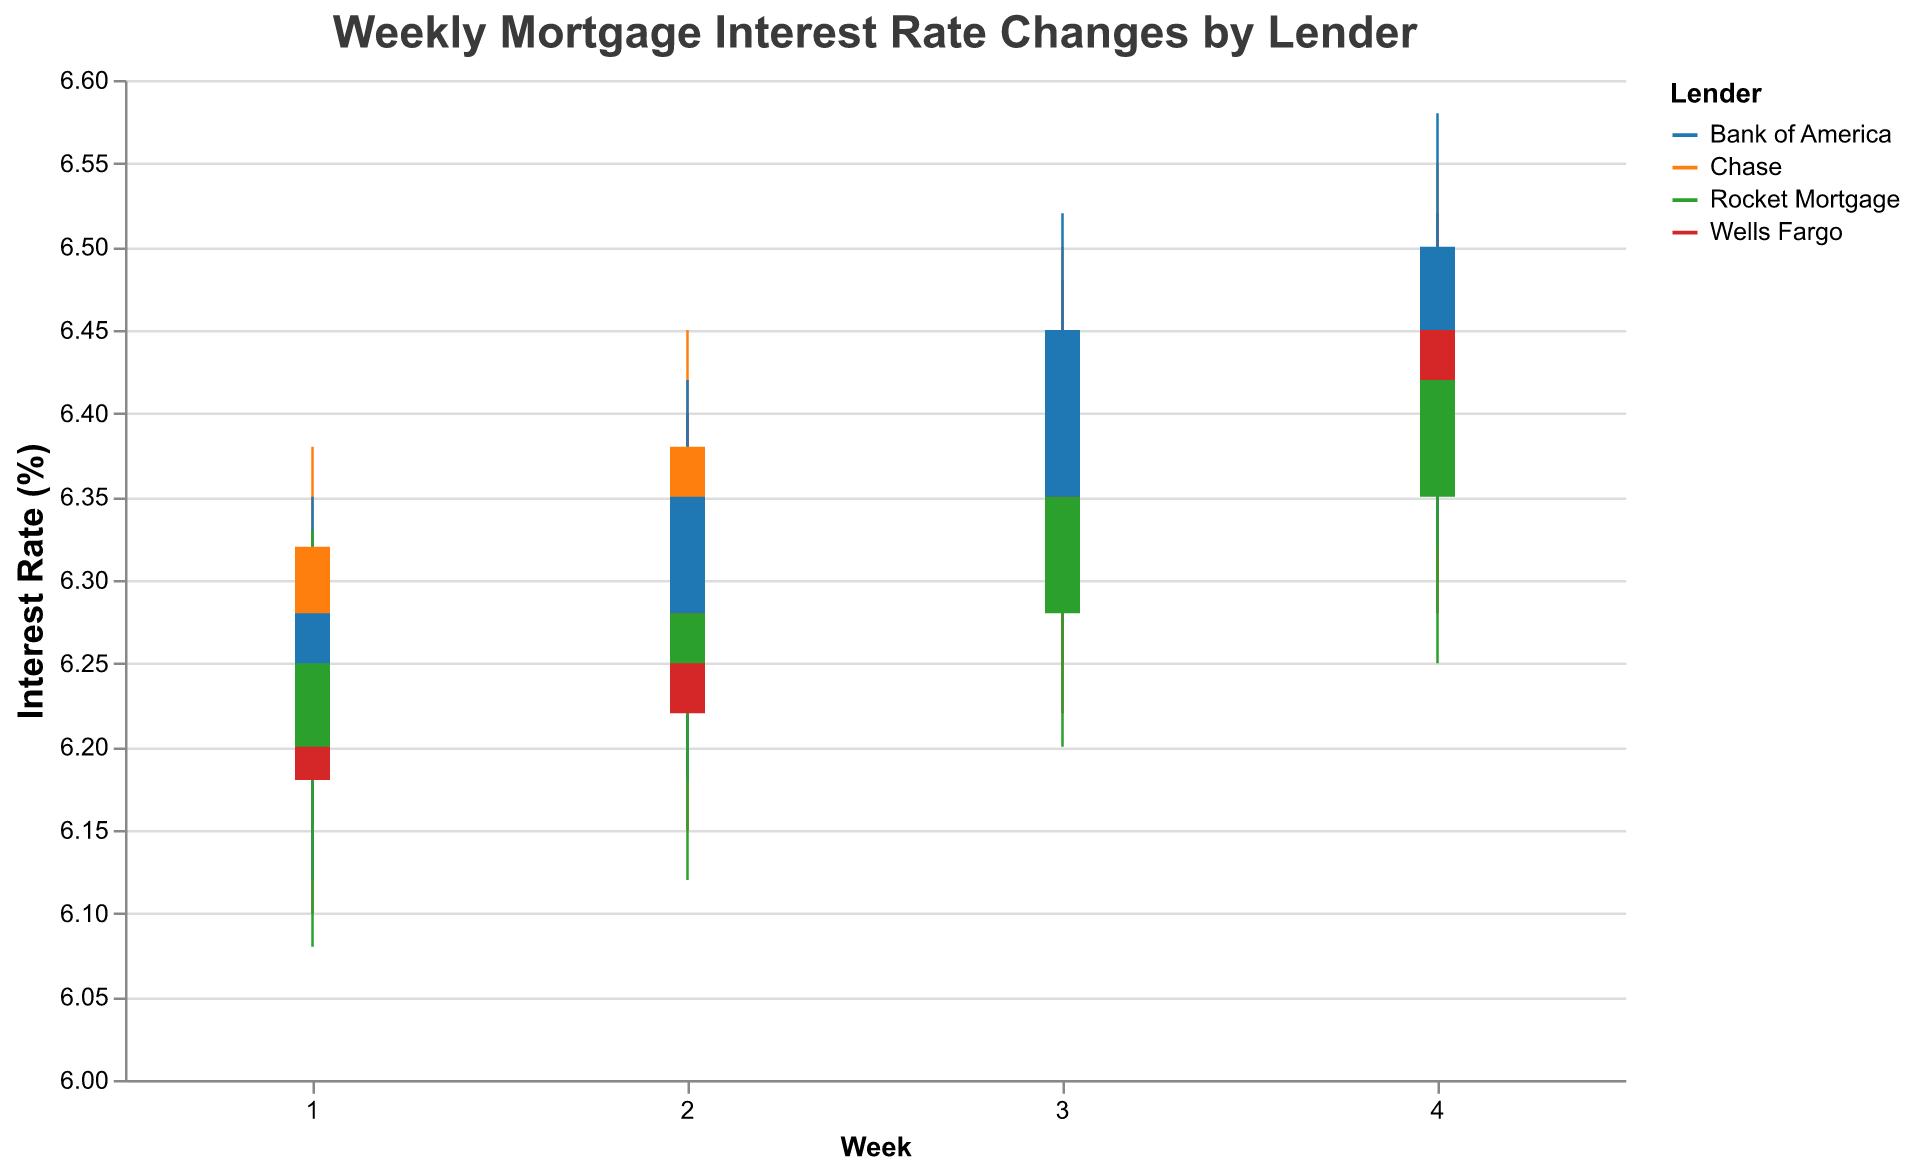What's the title of the figure? The title is prominently displayed at the top of the figure and reads "Weekly Mortgage Interest Rate Changes by Lender".
Answer: Weekly Mortgage Interest Rate Changes by Lender What are the lenders shown in the figure? The lenders are distinguished by different colors and indicated in the legends or tooltips. They are Chase, Wells Fargo, Bank of America, and Rocket Mortgage.
Answer: Chase, Wells Fargo, Bank of America, Rocket Mortgage Which week has the highest closing interest rates for Rocket Mortgage? By looking at the close values for Rocket Mortgage across all weeks, Week 4 has the highest closing rate of 6.42%.
Answer: Week 4 What is the highest interest rate recorded across all lenders? The highest rate can be found by comparing the high values for all lenders and weeks. The highest value is 6.58% shown by Bank of America in Week 4.
Answer: 6.58% In Week 2, which lender had the widest range between the high and low interest rates? Calculate the range (High - Low) for each lender in week 2. Chase: 6.45 - 6.20 = 0.25, Wells Fargo: 6.40 - 6.15 = 0.25, Bank of America: 6.42 - 6.18 = 0.24, Rocket Mortgage: 6.38 - 6.12 = 0.26. Rocket Mortgage has the widest range.
Answer: Rocket Mortgage What trend do you observe in Chase’s weekly closing rates? Chase’s weekly closing rates show a steady increase: Week 1: 6.32, Week 2: 6.38, Week 3: 6.42, Week 4: 6.48.
Answer: Increasing trend Which lender showed the lowest starting interest rate in Week 1? Check the open values for Week 1. Chase: 6.25, Wells Fargo: 6.18, Bank of America: 6.22, Rocket Mortgage: 6.20. The lowest starting rate was from Wells Fargo at 6.18%.
Answer: Wells Fargo What was the average closing interest rate for Bank of America over the four weeks? Add the closing rates for Bank of America across all weeks and divide by the number of weeks: (6.28 + 6.35 + 6.45 + 6.50) / 4 = 6.395%.
Answer: 6.395% How does Rocket Mortgage's closing interest rate compare from Week 1 to Week 4? Compare the closing rates for Rocket Mortgage in Week 1 and Week 4. Week 1: 6.25, Week 4: 6.42, showing an increase of 0.17%.
Answer: Increase of 0.17% Which lender had a lower closing interest rate in Week 3, Wells Fargo, or Rocket Mortgage? Compare the closing rates: Wells Fargo: 6.40, Rocket Mortgage: 6.35. Rocket Mortgage had the lower rate.
Answer: Rocket Mortgage 